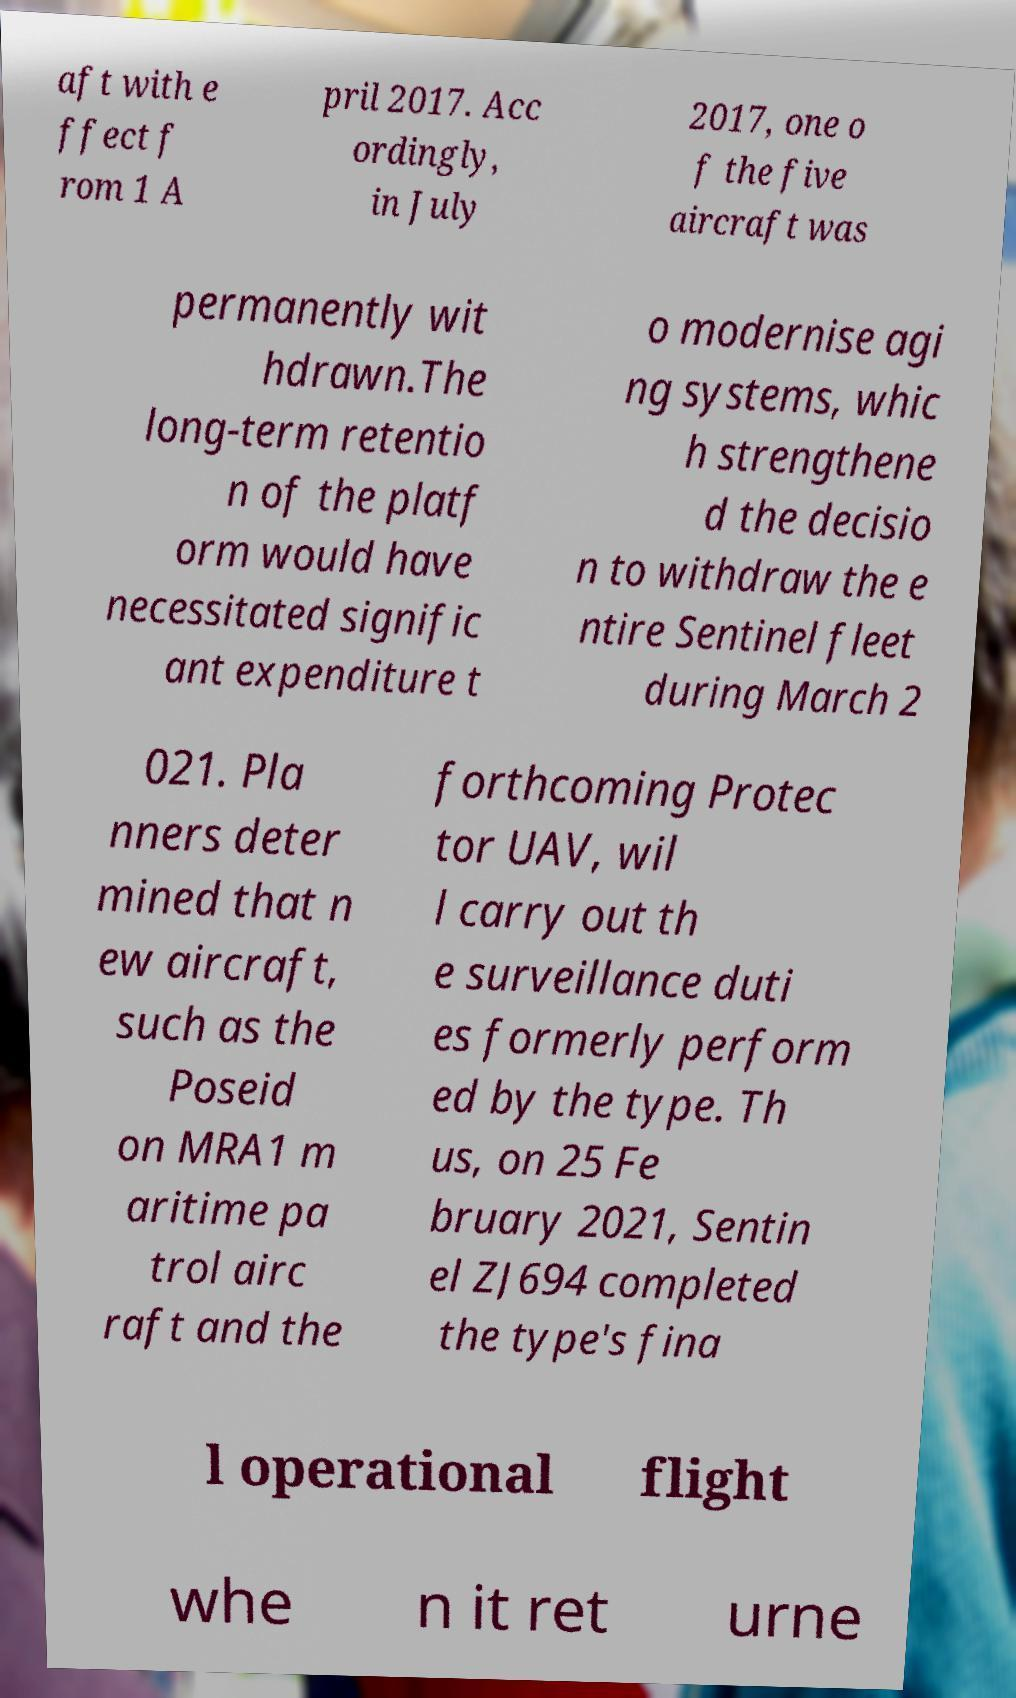Please read and relay the text visible in this image. What does it say? aft with e ffect f rom 1 A pril 2017. Acc ordingly, in July 2017, one o f the five aircraft was permanently wit hdrawn.The long-term retentio n of the platf orm would have necessitated signific ant expenditure t o modernise agi ng systems, whic h strengthene d the decisio n to withdraw the e ntire Sentinel fleet during March 2 021. Pla nners deter mined that n ew aircraft, such as the Poseid on MRA1 m aritime pa trol airc raft and the forthcoming Protec tor UAV, wil l carry out th e surveillance duti es formerly perform ed by the type. Th us, on 25 Fe bruary 2021, Sentin el ZJ694 completed the type's fina l operational flight whe n it ret urne 